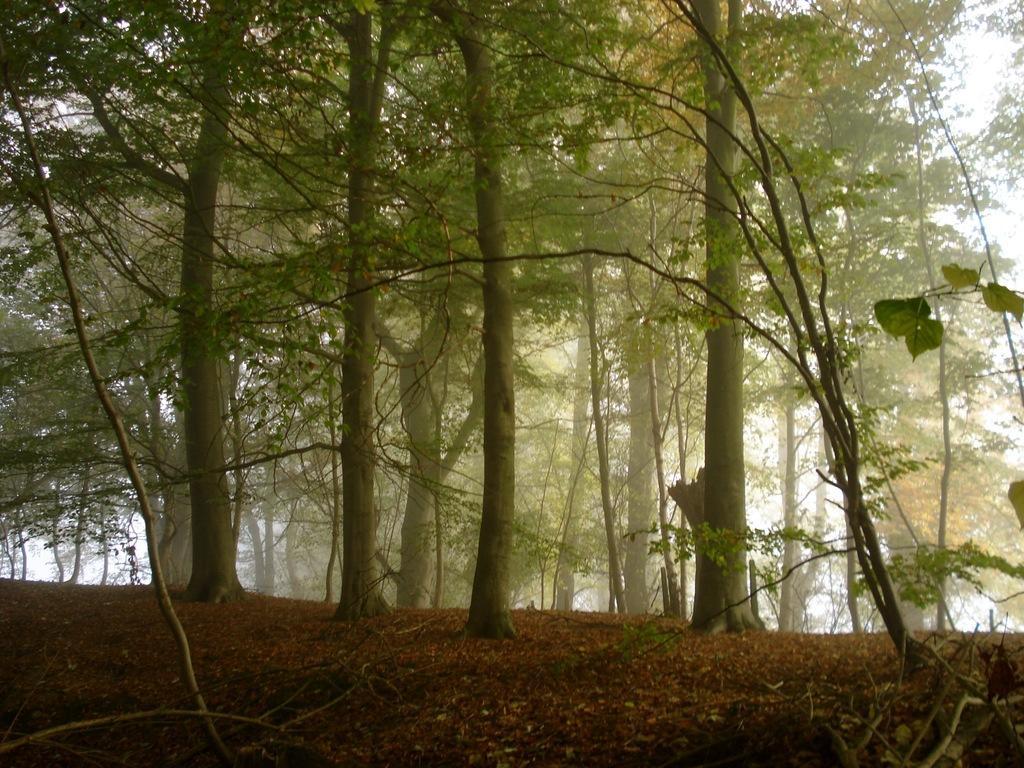In one or two sentences, can you explain what this image depicts? In this image I see the ground and I see number of trees and I see the sky in the background. 